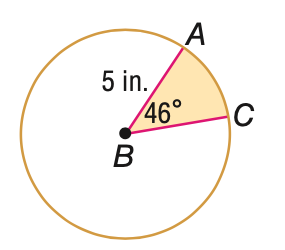Question: Find the area of the shaded sector. Round to the nearest tenth, if necessary.
Choices:
A. 10.0
B. 27.4
C. 65.5
D. 78.5
Answer with the letter. Answer: A 